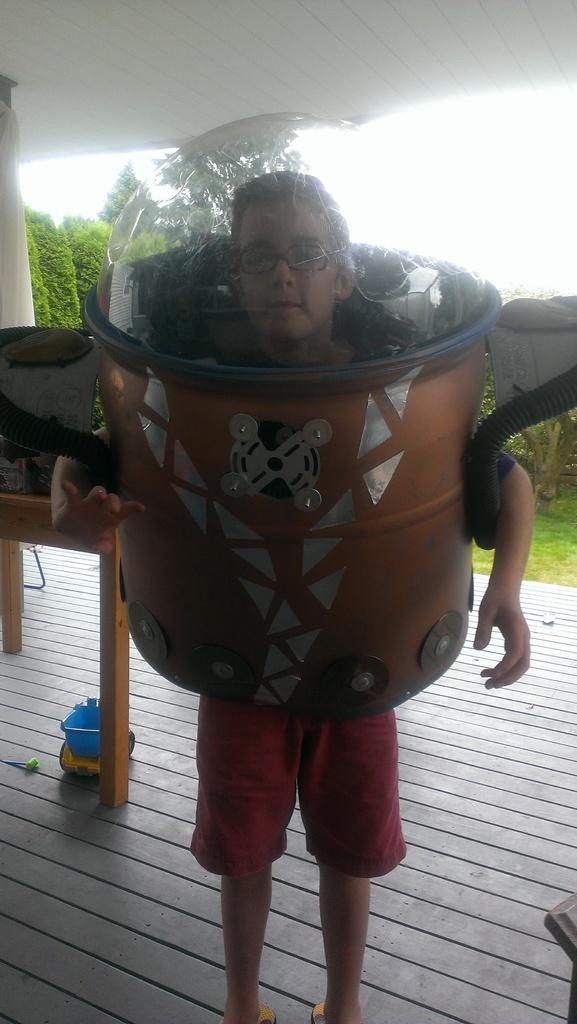What is the main subject in the foreground of the image? There is a boy in the foreground of the image. What can be seen on the boy's face? The boy is wearing spectacles. What is the boy wearing that is not clothing? The boy is wearing an object, which is likely a pair of spectacles. What part of the natural environment is visible in the image? The sky is visible in the image. What type of structure is present in the image? There is a roof in the image, which suggests a building or shelter. What type of vegetation is present in the image? Bushes are present in the image. What type of furniture is present in the image? There is a table in the image. What type of government is depicted in the image? There is no depiction of a government in the image; it features a boy, spectacles, a roof, bushes, and a table. How many cattle are present in the image? There are no cattle present in the image. 